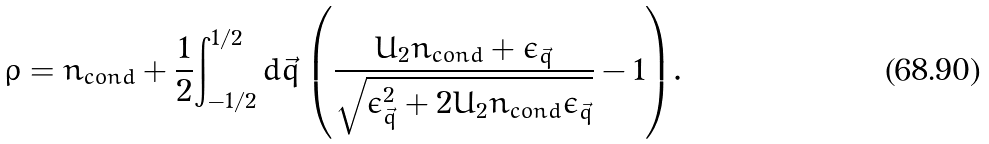<formula> <loc_0><loc_0><loc_500><loc_500>\rho = n _ { c o n d } + \frac { 1 } { 2 } { \int _ { - 1 / 2 } ^ { 1 / 2 } { d { \vec { q } } \left ( \frac { U _ { 2 } n _ { c o n d } + \epsilon _ { \vec { q } } } { \sqrt { \epsilon _ { \vec { q } } ^ { 2 } + 2 U _ { 2 } n _ { c o n d } \epsilon _ { \vec { q } } } } - 1 \right ) } } .</formula> 